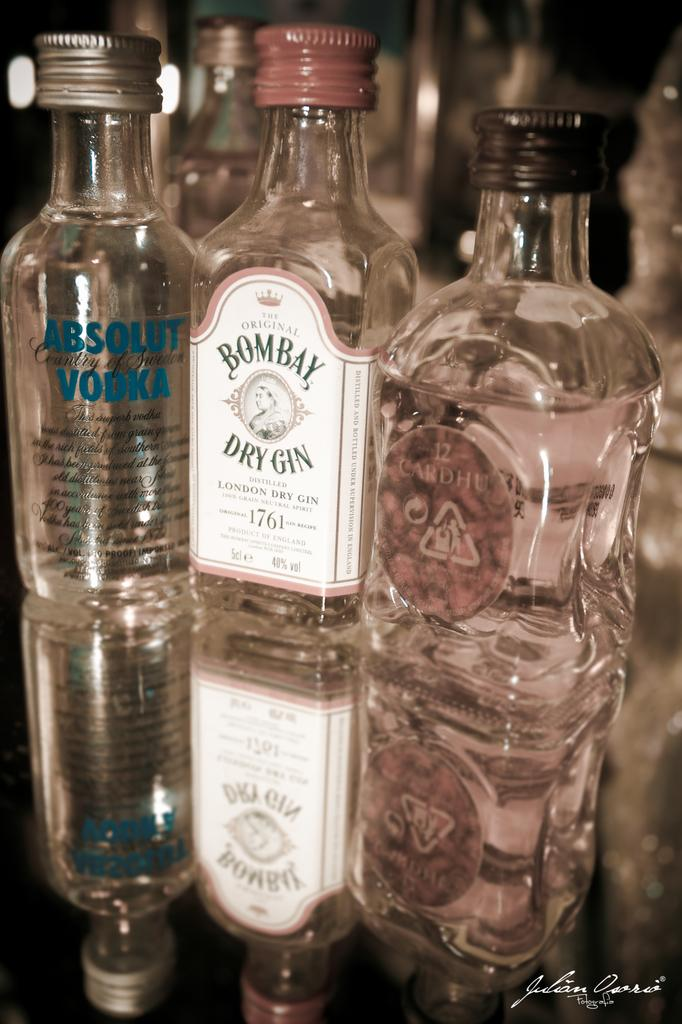<image>
Relay a brief, clear account of the picture shown. 3 bottles of alcohol with Absolut, Bombay, and unknown one. 